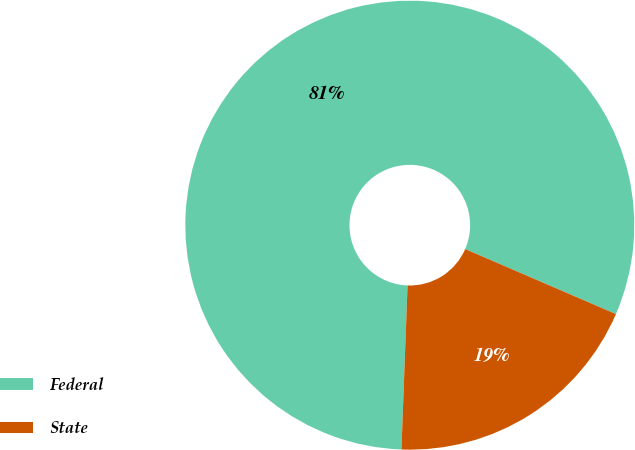Convert chart. <chart><loc_0><loc_0><loc_500><loc_500><pie_chart><fcel>Federal<fcel>State<nl><fcel>80.89%<fcel>19.11%<nl></chart> 